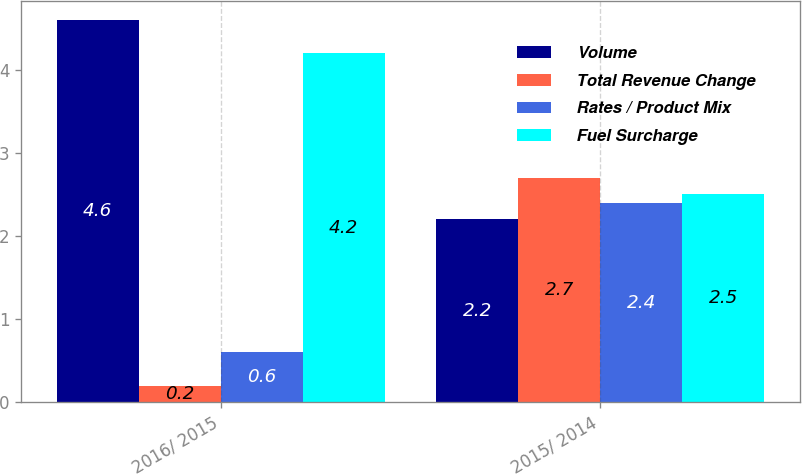<chart> <loc_0><loc_0><loc_500><loc_500><stacked_bar_chart><ecel><fcel>2016/ 2015<fcel>2015/ 2014<nl><fcel>Volume<fcel>4.6<fcel>2.2<nl><fcel>Total Revenue Change<fcel>0.2<fcel>2.7<nl><fcel>Rates / Product Mix<fcel>0.6<fcel>2.4<nl><fcel>Fuel Surcharge<fcel>4.2<fcel>2.5<nl></chart> 